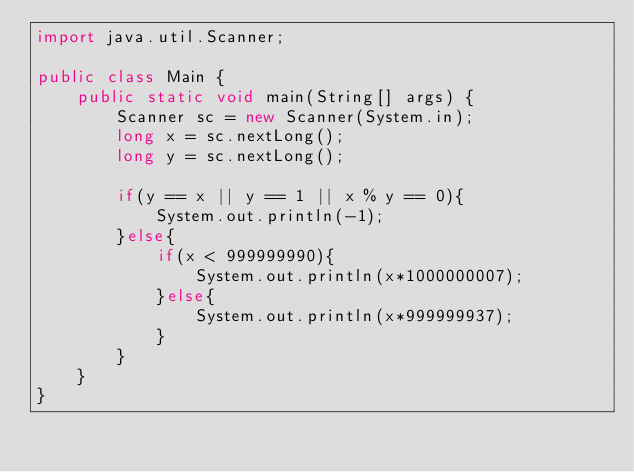Convert code to text. <code><loc_0><loc_0><loc_500><loc_500><_Java_>import java.util.Scanner;

public class Main {
    public static void main(String[] args) {
        Scanner sc = new Scanner(System.in);
        long x = sc.nextLong();
        long y = sc.nextLong();

        if(y == x || y == 1 || x % y == 0){
            System.out.println(-1);
        }else{
            if(x < 999999990){
                System.out.println(x*1000000007);
            }else{
                System.out.println(x*999999937);
            }
        }
    }
}</code> 